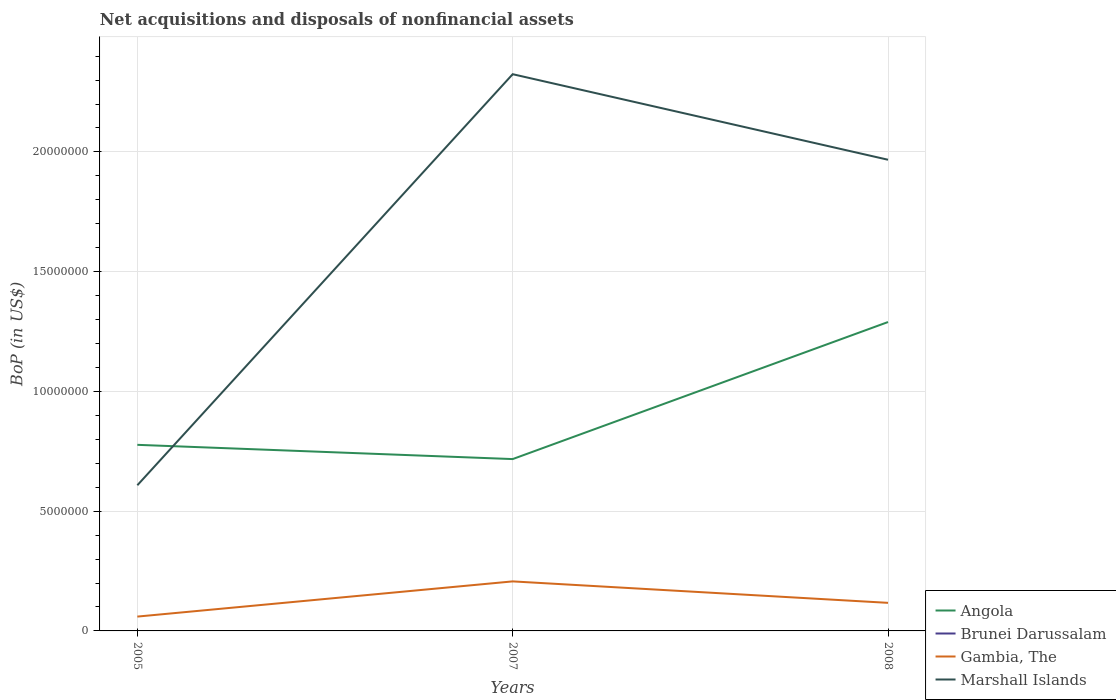Is the number of lines equal to the number of legend labels?
Provide a succinct answer. No. What is the total Balance of Payments in Marshall Islands in the graph?
Your answer should be compact. -1.36e+07. What is the difference between the highest and the second highest Balance of Payments in Angola?
Provide a succinct answer. 5.72e+06. Is the Balance of Payments in Marshall Islands strictly greater than the Balance of Payments in Gambia, The over the years?
Provide a short and direct response. No. How many lines are there?
Ensure brevity in your answer.  3. How many years are there in the graph?
Offer a very short reply. 3. What is the difference between two consecutive major ticks on the Y-axis?
Keep it short and to the point. 5.00e+06. Are the values on the major ticks of Y-axis written in scientific E-notation?
Your answer should be compact. No. Does the graph contain grids?
Give a very brief answer. Yes. How many legend labels are there?
Your answer should be very brief. 4. What is the title of the graph?
Keep it short and to the point. Net acquisitions and disposals of nonfinancial assets. What is the label or title of the Y-axis?
Provide a short and direct response. BoP (in US$). What is the BoP (in US$) in Angola in 2005?
Your answer should be compact. 7.77e+06. What is the BoP (in US$) in Brunei Darussalam in 2005?
Provide a succinct answer. 0. What is the BoP (in US$) of Gambia, The in 2005?
Ensure brevity in your answer.  5.98e+05. What is the BoP (in US$) in Marshall Islands in 2005?
Offer a terse response. 6.08e+06. What is the BoP (in US$) of Angola in 2007?
Offer a very short reply. 7.17e+06. What is the BoP (in US$) of Gambia, The in 2007?
Offer a very short reply. 2.07e+06. What is the BoP (in US$) in Marshall Islands in 2007?
Your answer should be compact. 2.32e+07. What is the BoP (in US$) of Angola in 2008?
Provide a short and direct response. 1.29e+07. What is the BoP (in US$) in Brunei Darussalam in 2008?
Provide a succinct answer. 0. What is the BoP (in US$) in Gambia, The in 2008?
Provide a succinct answer. 1.17e+06. What is the BoP (in US$) of Marshall Islands in 2008?
Provide a succinct answer. 1.97e+07. Across all years, what is the maximum BoP (in US$) in Angola?
Provide a short and direct response. 1.29e+07. Across all years, what is the maximum BoP (in US$) of Gambia, The?
Your answer should be very brief. 2.07e+06. Across all years, what is the maximum BoP (in US$) in Marshall Islands?
Provide a succinct answer. 2.32e+07. Across all years, what is the minimum BoP (in US$) of Angola?
Provide a short and direct response. 7.17e+06. Across all years, what is the minimum BoP (in US$) in Gambia, The?
Offer a very short reply. 5.98e+05. Across all years, what is the minimum BoP (in US$) of Marshall Islands?
Your response must be concise. 6.08e+06. What is the total BoP (in US$) in Angola in the graph?
Your answer should be compact. 2.78e+07. What is the total BoP (in US$) in Gambia, The in the graph?
Your answer should be very brief. 3.84e+06. What is the total BoP (in US$) of Marshall Islands in the graph?
Your answer should be compact. 4.90e+07. What is the difference between the BoP (in US$) of Angola in 2005 and that in 2007?
Ensure brevity in your answer.  5.95e+05. What is the difference between the BoP (in US$) of Gambia, The in 2005 and that in 2007?
Ensure brevity in your answer.  -1.47e+06. What is the difference between the BoP (in US$) in Marshall Islands in 2005 and that in 2007?
Keep it short and to the point. -1.72e+07. What is the difference between the BoP (in US$) in Angola in 2005 and that in 2008?
Provide a succinct answer. -5.13e+06. What is the difference between the BoP (in US$) of Gambia, The in 2005 and that in 2008?
Ensure brevity in your answer.  -5.74e+05. What is the difference between the BoP (in US$) in Marshall Islands in 2005 and that in 2008?
Make the answer very short. -1.36e+07. What is the difference between the BoP (in US$) in Angola in 2007 and that in 2008?
Your response must be concise. -5.72e+06. What is the difference between the BoP (in US$) in Gambia, The in 2007 and that in 2008?
Ensure brevity in your answer.  8.96e+05. What is the difference between the BoP (in US$) of Marshall Islands in 2007 and that in 2008?
Offer a terse response. 3.57e+06. What is the difference between the BoP (in US$) of Angola in 2005 and the BoP (in US$) of Gambia, The in 2007?
Provide a succinct answer. 5.70e+06. What is the difference between the BoP (in US$) in Angola in 2005 and the BoP (in US$) in Marshall Islands in 2007?
Provide a short and direct response. -1.55e+07. What is the difference between the BoP (in US$) of Gambia, The in 2005 and the BoP (in US$) of Marshall Islands in 2007?
Make the answer very short. -2.26e+07. What is the difference between the BoP (in US$) in Angola in 2005 and the BoP (in US$) in Gambia, The in 2008?
Provide a succinct answer. 6.60e+06. What is the difference between the BoP (in US$) of Angola in 2005 and the BoP (in US$) of Marshall Islands in 2008?
Your answer should be compact. -1.19e+07. What is the difference between the BoP (in US$) in Gambia, The in 2005 and the BoP (in US$) in Marshall Islands in 2008?
Your answer should be compact. -1.91e+07. What is the difference between the BoP (in US$) of Angola in 2007 and the BoP (in US$) of Gambia, The in 2008?
Ensure brevity in your answer.  6.00e+06. What is the difference between the BoP (in US$) in Angola in 2007 and the BoP (in US$) in Marshall Islands in 2008?
Keep it short and to the point. -1.25e+07. What is the difference between the BoP (in US$) in Gambia, The in 2007 and the BoP (in US$) in Marshall Islands in 2008?
Make the answer very short. -1.76e+07. What is the average BoP (in US$) in Angola per year?
Make the answer very short. 9.28e+06. What is the average BoP (in US$) of Gambia, The per year?
Provide a short and direct response. 1.28e+06. What is the average BoP (in US$) of Marshall Islands per year?
Your answer should be compact. 1.63e+07. In the year 2005, what is the difference between the BoP (in US$) in Angola and BoP (in US$) in Gambia, The?
Provide a short and direct response. 7.17e+06. In the year 2005, what is the difference between the BoP (in US$) in Angola and BoP (in US$) in Marshall Islands?
Make the answer very short. 1.69e+06. In the year 2005, what is the difference between the BoP (in US$) of Gambia, The and BoP (in US$) of Marshall Islands?
Give a very brief answer. -5.48e+06. In the year 2007, what is the difference between the BoP (in US$) of Angola and BoP (in US$) of Gambia, The?
Your answer should be compact. 5.11e+06. In the year 2007, what is the difference between the BoP (in US$) in Angola and BoP (in US$) in Marshall Islands?
Ensure brevity in your answer.  -1.61e+07. In the year 2007, what is the difference between the BoP (in US$) of Gambia, The and BoP (in US$) of Marshall Islands?
Your response must be concise. -2.12e+07. In the year 2008, what is the difference between the BoP (in US$) of Angola and BoP (in US$) of Gambia, The?
Ensure brevity in your answer.  1.17e+07. In the year 2008, what is the difference between the BoP (in US$) of Angola and BoP (in US$) of Marshall Islands?
Provide a short and direct response. -6.78e+06. In the year 2008, what is the difference between the BoP (in US$) of Gambia, The and BoP (in US$) of Marshall Islands?
Provide a short and direct response. -1.85e+07. What is the ratio of the BoP (in US$) of Angola in 2005 to that in 2007?
Provide a succinct answer. 1.08. What is the ratio of the BoP (in US$) in Gambia, The in 2005 to that in 2007?
Give a very brief answer. 0.29. What is the ratio of the BoP (in US$) of Marshall Islands in 2005 to that in 2007?
Offer a very short reply. 0.26. What is the ratio of the BoP (in US$) in Angola in 2005 to that in 2008?
Provide a short and direct response. 0.6. What is the ratio of the BoP (in US$) of Gambia, The in 2005 to that in 2008?
Your response must be concise. 0.51. What is the ratio of the BoP (in US$) in Marshall Islands in 2005 to that in 2008?
Provide a succinct answer. 0.31. What is the ratio of the BoP (in US$) in Angola in 2007 to that in 2008?
Provide a short and direct response. 0.56. What is the ratio of the BoP (in US$) of Gambia, The in 2007 to that in 2008?
Offer a very short reply. 1.76. What is the ratio of the BoP (in US$) in Marshall Islands in 2007 to that in 2008?
Ensure brevity in your answer.  1.18. What is the difference between the highest and the second highest BoP (in US$) of Angola?
Your answer should be compact. 5.13e+06. What is the difference between the highest and the second highest BoP (in US$) of Gambia, The?
Your response must be concise. 8.96e+05. What is the difference between the highest and the second highest BoP (in US$) of Marshall Islands?
Provide a succinct answer. 3.57e+06. What is the difference between the highest and the lowest BoP (in US$) of Angola?
Keep it short and to the point. 5.72e+06. What is the difference between the highest and the lowest BoP (in US$) of Gambia, The?
Keep it short and to the point. 1.47e+06. What is the difference between the highest and the lowest BoP (in US$) of Marshall Islands?
Give a very brief answer. 1.72e+07. 